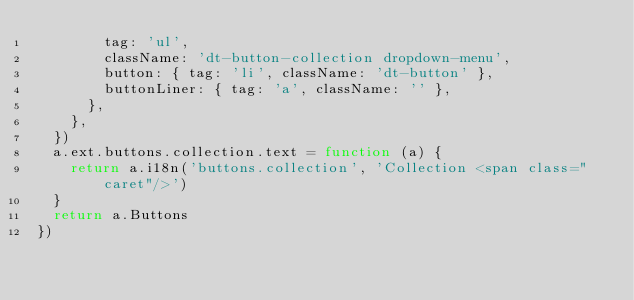Convert code to text. <code><loc_0><loc_0><loc_500><loc_500><_JavaScript_>        tag: 'ul',
        className: 'dt-button-collection dropdown-menu',
        button: { tag: 'li', className: 'dt-button' },
        buttonLiner: { tag: 'a', className: '' },
      },
    },
  })
  a.ext.buttons.collection.text = function (a) {
    return a.i18n('buttons.collection', 'Collection <span class="caret"/>')
  }
  return a.Buttons
})
</code> 